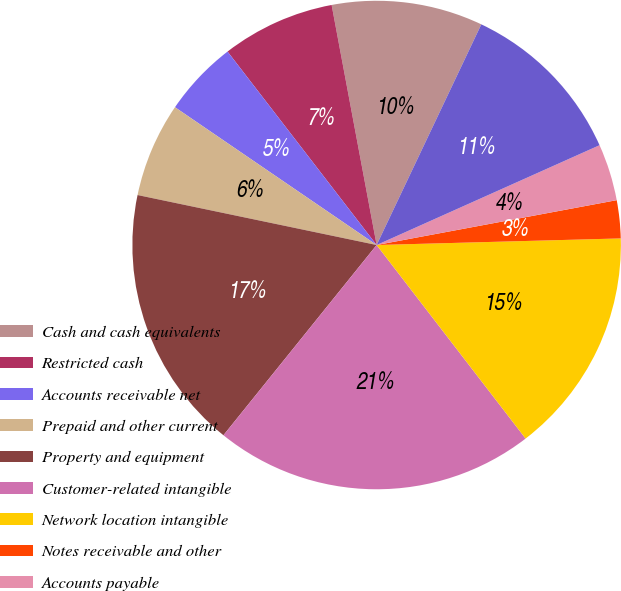<chart> <loc_0><loc_0><loc_500><loc_500><pie_chart><fcel>Cash and cash equivalents<fcel>Restricted cash<fcel>Accounts receivable net<fcel>Prepaid and other current<fcel>Property and equipment<fcel>Customer-related intangible<fcel>Network location intangible<fcel>Notes receivable and other<fcel>Accounts payable<fcel>Accrued expenses<nl><fcel>10.0%<fcel>7.5%<fcel>5.01%<fcel>6.26%<fcel>17.49%<fcel>21.23%<fcel>14.99%<fcel>2.51%<fcel>3.76%<fcel>11.25%<nl></chart> 